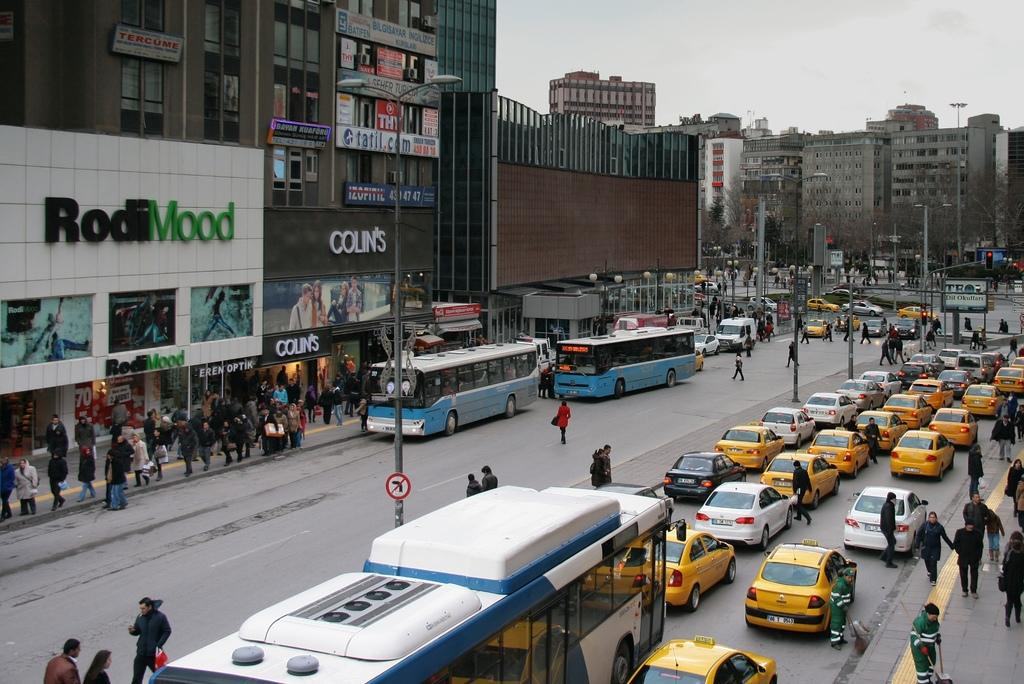<image>
Present a compact description of the photo's key features. A busy street filled with cars and people in front of a shop called Rodimmood 